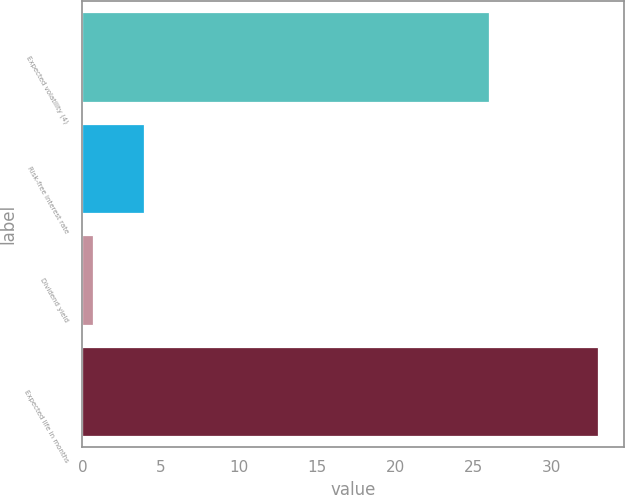Convert chart. <chart><loc_0><loc_0><loc_500><loc_500><bar_chart><fcel>Expected volatility (4)<fcel>Risk-free interest rate<fcel>Dividend yield<fcel>Expected life in months<nl><fcel>26<fcel>3.93<fcel>0.7<fcel>33<nl></chart> 